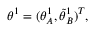<formula> <loc_0><loc_0><loc_500><loc_500>{ \theta } ^ { 1 } = ( { \theta } _ { A } ^ { 1 } , \tilde { \theta } _ { B } ^ { 1 } ) ^ { T } ,</formula> 